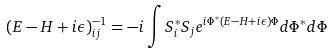Convert formula to latex. <formula><loc_0><loc_0><loc_500><loc_500>( E - H + i \epsilon ) _ { i j } ^ { - 1 } = - i \int S ^ { * } _ { i } S _ { j } e ^ { i \Phi ^ { * } ( E - H + i \epsilon ) \Phi } d \Phi ^ { * } d \Phi</formula> 